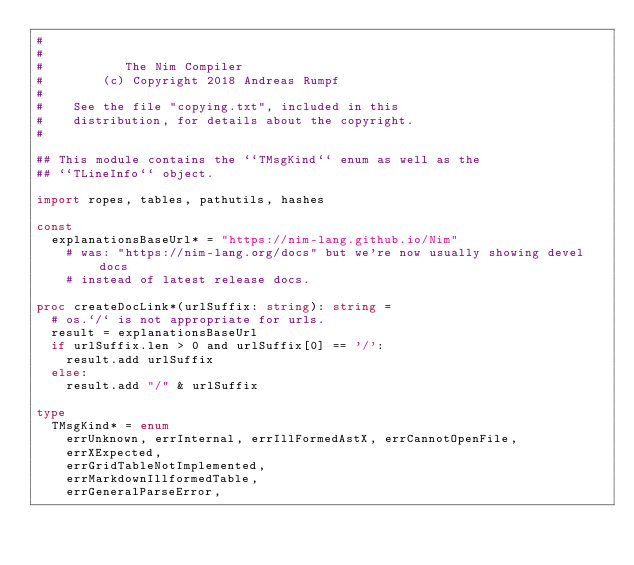Convert code to text. <code><loc_0><loc_0><loc_500><loc_500><_Nim_>#
#
#           The Nim Compiler
#        (c) Copyright 2018 Andreas Rumpf
#
#    See the file "copying.txt", included in this
#    distribution, for details about the copyright.
#

## This module contains the ``TMsgKind`` enum as well as the
## ``TLineInfo`` object.

import ropes, tables, pathutils, hashes

const
  explanationsBaseUrl* = "https://nim-lang.github.io/Nim"
    # was: "https://nim-lang.org/docs" but we're now usually showing devel docs
    # instead of latest release docs.

proc createDocLink*(urlSuffix: string): string =
  # os.`/` is not appropriate for urls.
  result = explanationsBaseUrl
  if urlSuffix.len > 0 and urlSuffix[0] == '/':
    result.add urlSuffix
  else:
    result.add "/" & urlSuffix

type
  TMsgKind* = enum
    errUnknown, errInternal, errIllFormedAstX, errCannotOpenFile,
    errXExpected,
    errGridTableNotImplemented,
    errMarkdownIllformedTable,
    errGeneralParseError,</code> 